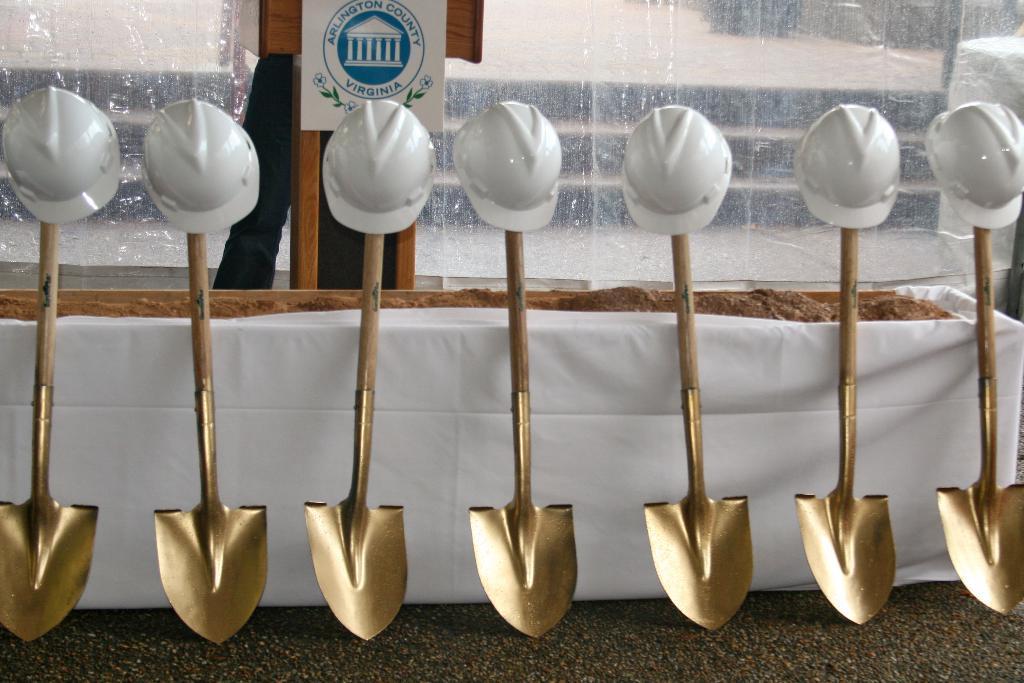How would you summarize this image in a sentence or two? In this image, we can see glass trowels and in the background, there is a glass and a name board. 